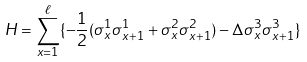Convert formula to latex. <formula><loc_0><loc_0><loc_500><loc_500>H = \sum _ { x = 1 } ^ { \ell } \{ - \frac { 1 } { 2 } ( \sigma _ { x } ^ { 1 } \sigma _ { x + 1 } ^ { 1 } + \sigma _ { x } ^ { 2 } \sigma _ { x + 1 } ^ { 2 } ) - \Delta \sigma _ { x } ^ { 3 } \sigma _ { x + 1 } ^ { 3 } \}</formula> 